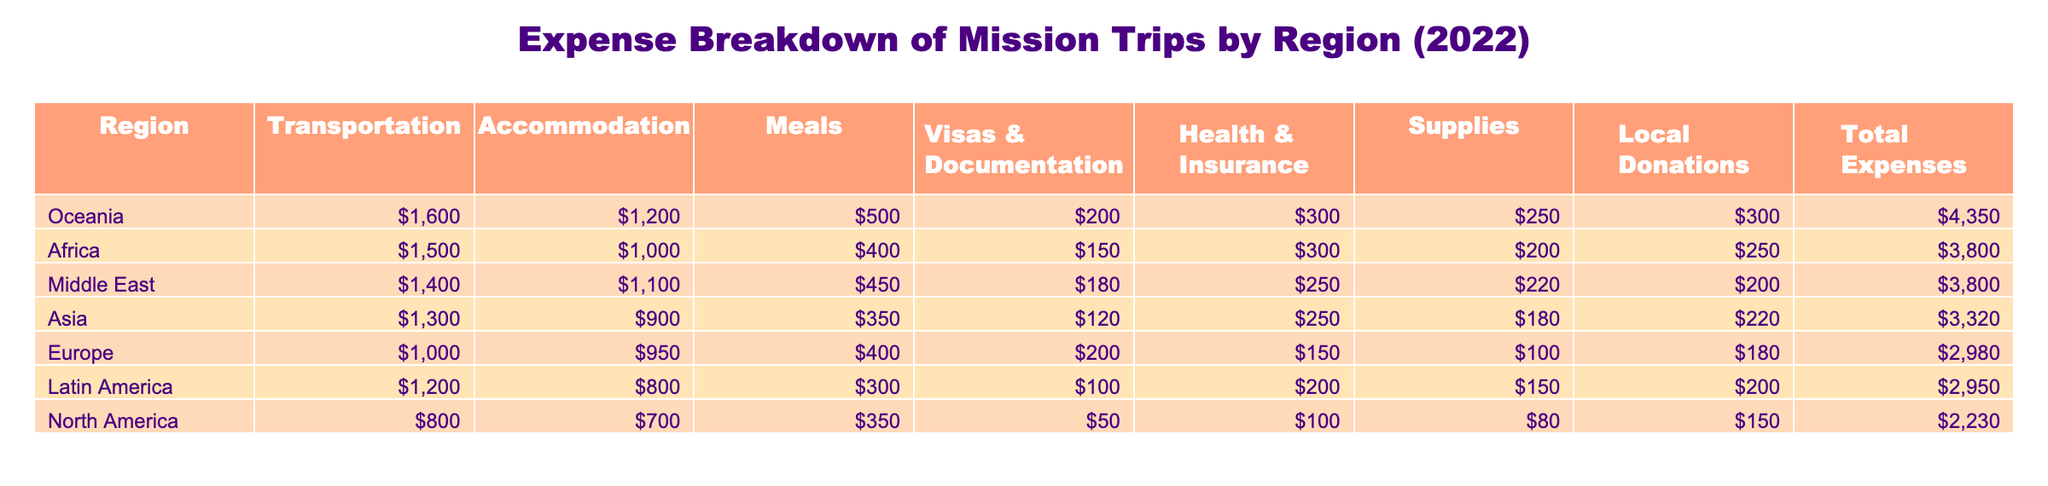What region had the highest total expenses for mission trips in 2022? By looking at the "Total Expenses" column in the table, we can see that Oceania has the highest total expenses of 4,350.
Answer: Oceania What were the total expenses for mission trips to Africa? The table indicates that the total expenses for Africa is 3,800.
Answer: 3,800 Which region had the lowest expense on transportation? By checking the "Transportation" column, North America has the lowest transportation expense of 800.
Answer: North America What is the average total expense across all regions? To find the average, we sum the total expenses: 2,950 + 3,800 + 3,320 + 2,980 + 2,230 + 3,800 + 4,350 = 22,430. There are 7 regions, so we divide: 22,430 / 7 ≈ 3,191.43.
Answer: 3,191 Does Europe have higher accommodation expenses than Asia? When comparing the "Accommodation" expenses, Europe has 950 while Asia has 900, which means Europe does have higher accommodation expenses.
Answer: Yes What is the difference in total expenses between Latin America and North America? The total expense for Latin America is 2,950 and for North America is 2,230. The difference is calculated as 2,950 - 2,230 = 720.
Answer: 720 Which region spends more on visas and documentation, Middle East or Oceania? The "Visas & Documentation" column shows that the Middle East spends 180, while Oceania spends 200. Since 200 is greater than 180, Oceania spends more.
Answer: Oceania What are the total expenses for regions with transportation costs below 1,300? The regions with transportation costs below 1,300 are North America (800), Europe (1,000), and Latin America (1,200). Their total expenses are 2,230 (North America) + 2,980 (Europe) + 2,950 (Latin America) = 8,160.
Answer: 8,160 Is the total expenses for Asia greater than the sum of total expenses for North America and Europe? The total expenses for Asia is 3,320. The sum of North America (2,230) and Europe (2,980) is 5,210. Since 3,320 is less than 5,210, the statement is false.
Answer: No 